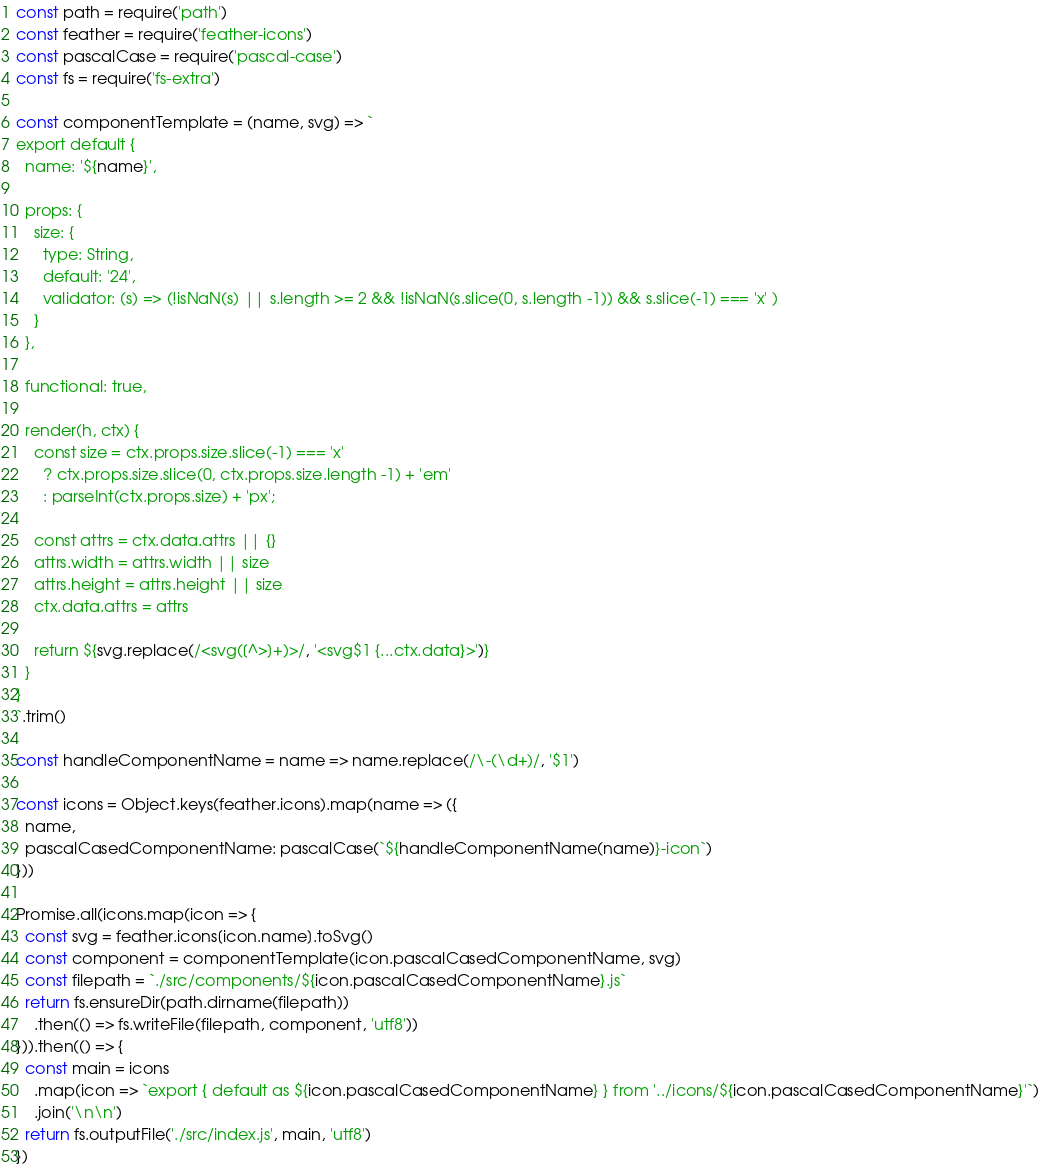<code> <loc_0><loc_0><loc_500><loc_500><_JavaScript_>const path = require('path')
const feather = require('feather-icons')
const pascalCase = require('pascal-case')
const fs = require('fs-extra')

const componentTemplate = (name, svg) => `
export default {
  name: '${name}',
  
  props: {
    size: {
      type: String,
      default: '24',
      validator: (s) => (!isNaN(s) || s.length >= 2 && !isNaN(s.slice(0, s.length -1)) && s.slice(-1) === 'x' )
    }
  },

  functional: true,

  render(h, ctx) {
    const size = ctx.props.size.slice(-1) === 'x' 
      ? ctx.props.size.slice(0, ctx.props.size.length -1) + 'em'
      : parseInt(ctx.props.size) + 'px';

    const attrs = ctx.data.attrs || {}
    attrs.width = attrs.width || size
    attrs.height = attrs.height || size
    ctx.data.attrs = attrs
  
    return ${svg.replace(/<svg([^>]+)>/, '<svg$1 {...ctx.data}>')}
  }
}
`.trim()

const handleComponentName = name => name.replace(/\-(\d+)/, '$1')

const icons = Object.keys(feather.icons).map(name => ({
  name,
  pascalCasedComponentName: pascalCase(`${handleComponentName(name)}-icon`)
}))

Promise.all(icons.map(icon => {
  const svg = feather.icons[icon.name].toSvg()
  const component = componentTemplate(icon.pascalCasedComponentName, svg)
  const filepath = `./src/components/${icon.pascalCasedComponentName}.js`
  return fs.ensureDir(path.dirname(filepath))
    .then(() => fs.writeFile(filepath, component, 'utf8'))
})).then(() => {
  const main = icons
    .map(icon => `export { default as ${icon.pascalCasedComponentName} } from '../icons/${icon.pascalCasedComponentName}'`)
    .join('\n\n')
  return fs.outputFile('./src/index.js', main, 'utf8')
})
</code> 